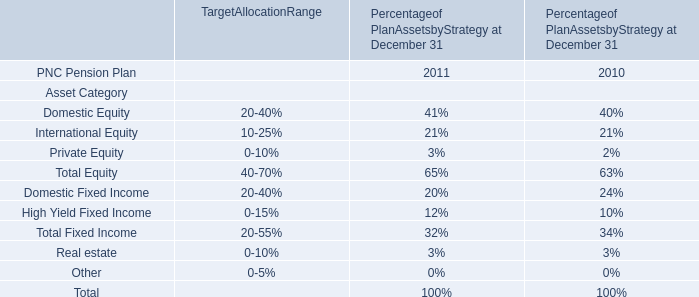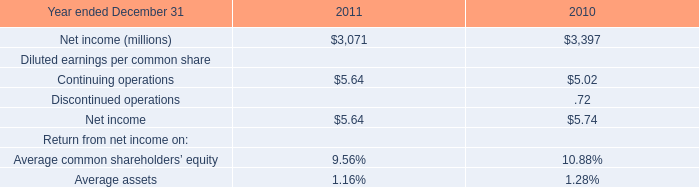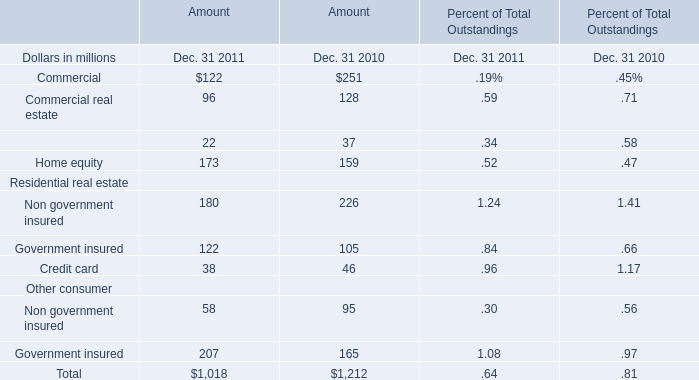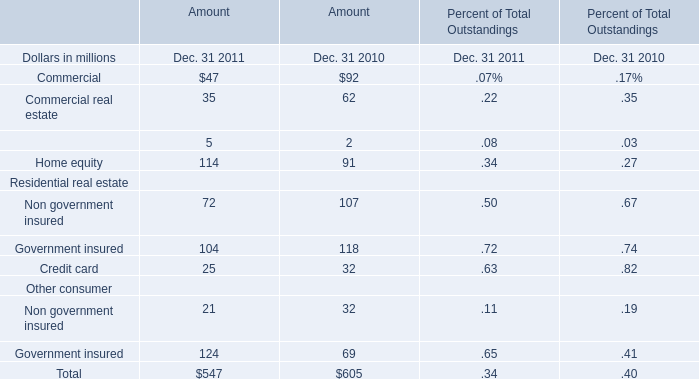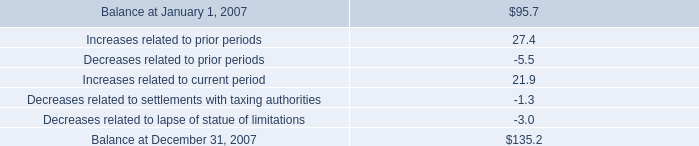What is the sum of Residential real estate in 2011? (in million) 
Computations: ((180 + 122) + 38)
Answer: 340.0. 